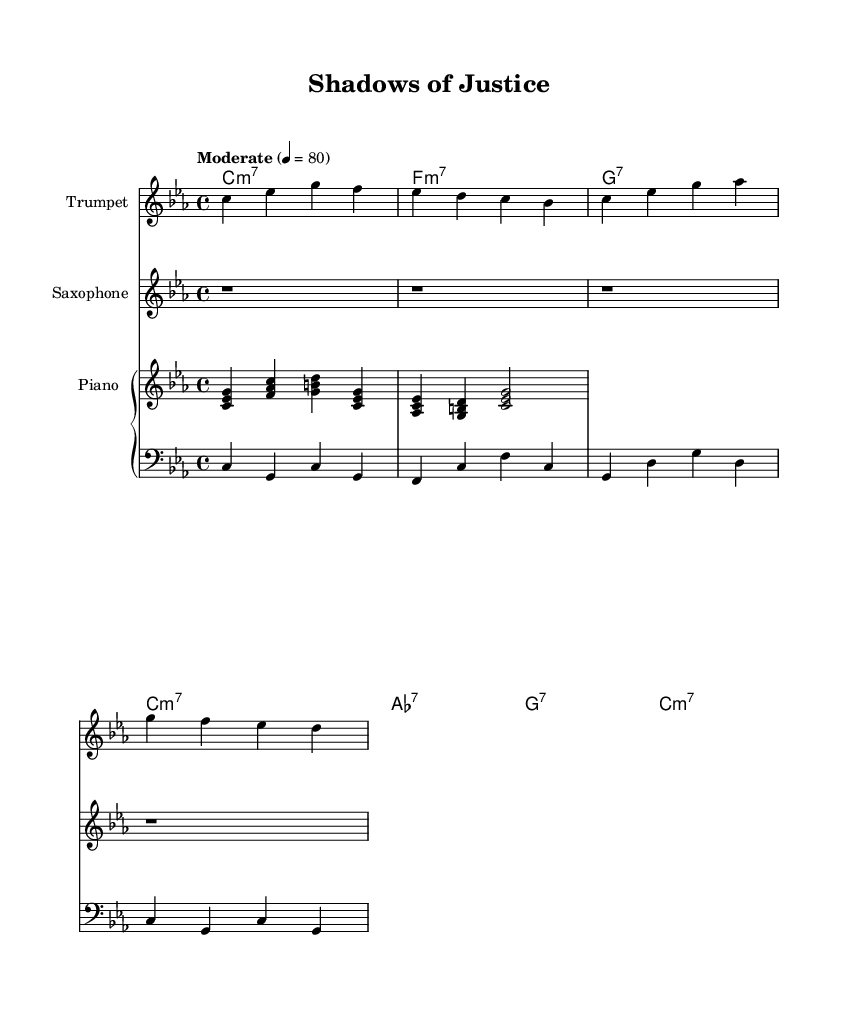What is the key signature of this music? The key signature is indicated at the beginning of the staff, and it shows three flats in the key signature, which corresponds to C minor.
Answer: C minor What is the time signature of this music? The time signature is found at the beginning of the score, displaying the fraction 4/4, meaning four beats per measure.
Answer: 4/4 What is the tempo marking of this music? The tempo marking is located above the staff and states "Moderate" with a metronome marking of 80, indicating the speed of the piece.
Answer: Moderate 4 equals 80 How many measures are in the trumpet part? By counting the number of vertical bar lines in the trumpet part, we can see there are four measures marked by the bar lines.
Answer: Four What is the first chord played in the piano part? The first chord is shown in the piano part, using the notes C, E-flat, and G played simultaneously, which identifies it as a C minor chord.
Answer: C minor Which instruments are included in this piece? The instruments are listed at the beginning of each staff in the score layout, showing trumpet, saxophone, piano, and bass as the instruments used.
Answer: Trumpet, saxophone, piano, bass What type of seventh chord appears in the chord names section? The chord names at the bottom indicate C minor 7, F minor 7, and A-flat 7, thus showcasing the different types of seventh chords employed in the piece.
Answer: C minor 7, F minor 7, A-flat 7 